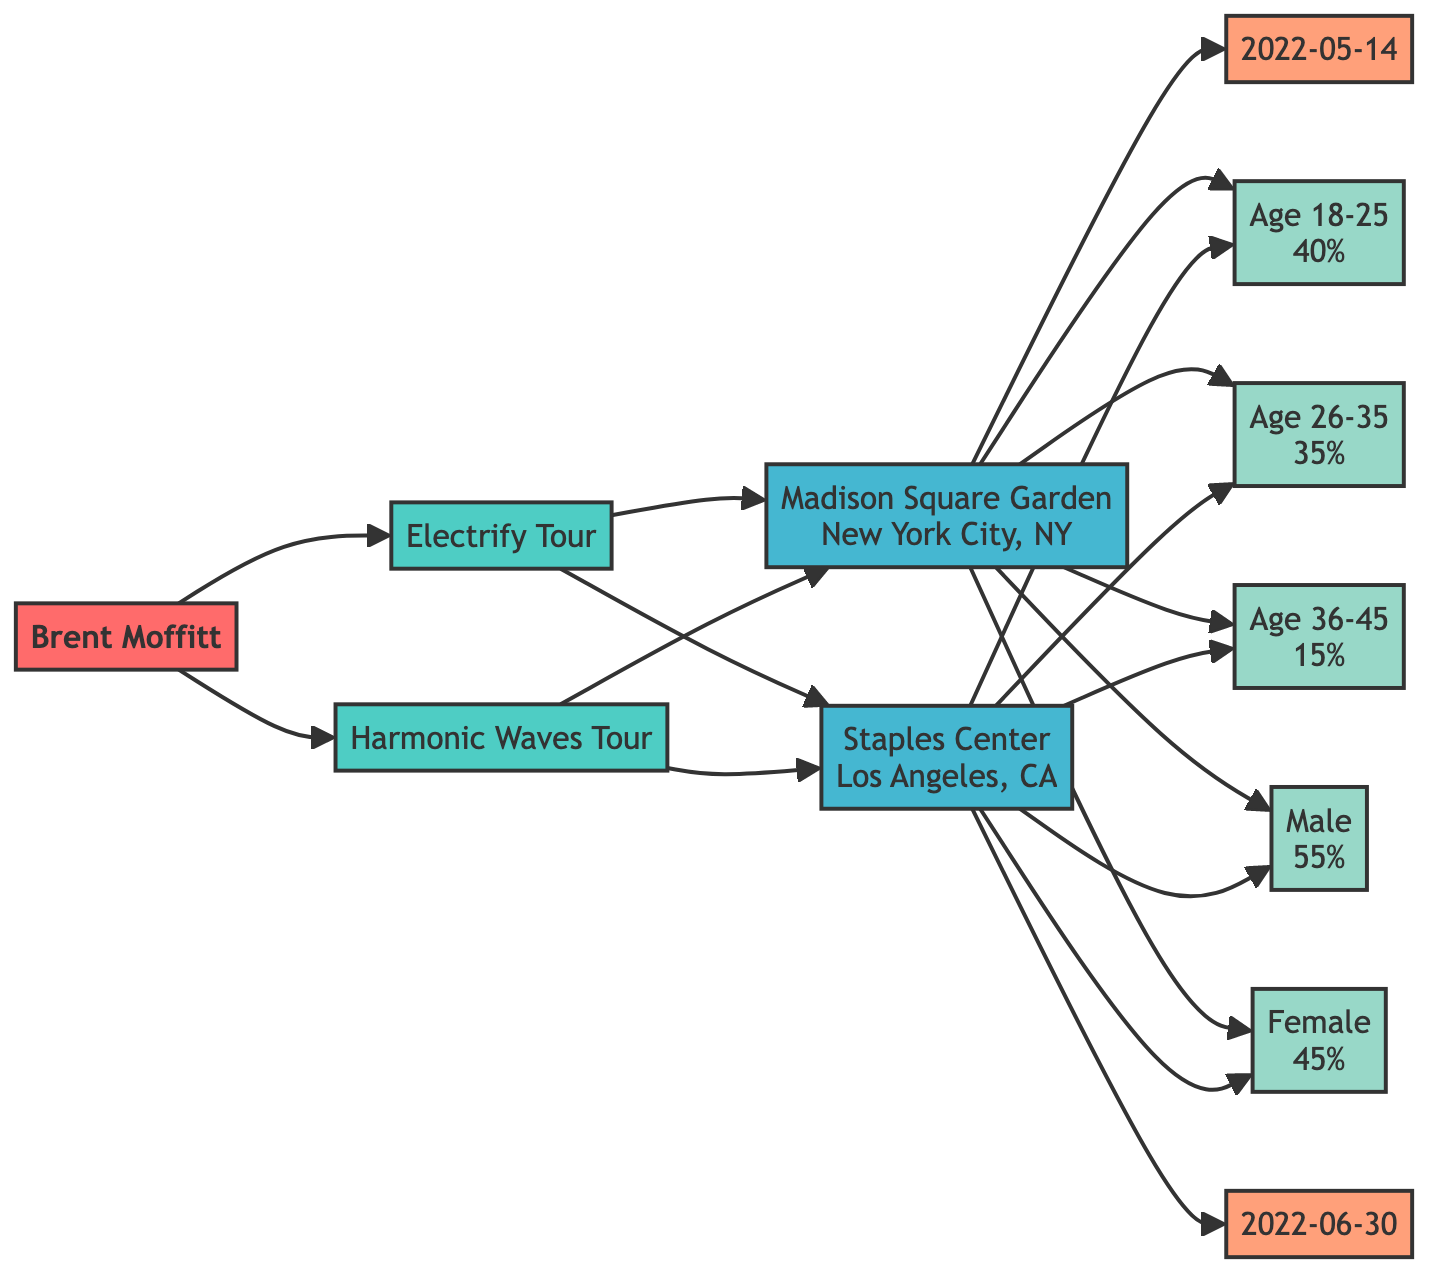What are the two concert tours associated with Brent Moffitt? The diagram shows that Brent Moffitt is associated with two concert tours: "Electrify Tour" and "Harmonic Waves Tour." This information can be directly seen as nodes linked to the artist node.
Answer: Electrify Tour, Harmonic Waves Tour How many venues are associated with each tour? Each tour in the diagram has connections to two venues: "Madison Square Garden" and "Staples Center." This can be verified by counting the edges from the tour nodes to the venue nodes.
Answer: 2 What is the date associated with the Staples Center venue? The diagram links the Staples Center venue to a specific date node, "2022-06-30." Following the edge from the venue node to the date node gives the information.
Answer: 2022-06-30 What percentage of the audience at Madison Square Garden is between the ages of 18-25? The demographic node "Age 18-25" attributes a percentage of "40%" connected directly to the Madison Square Garden venue node. Thus, the percentage is easily extractable from the diagram.
Answer: 40% Which demographic has the highest percentage for the audience at Madison Square Garden? The diagram shows various demographic nodes linked to Madison Square Garden. Scanning through these nodes, "Male" with "55%" is visible, indicating it has the highest percentage.
Answer: Male Which concert tour took place before 2022-06-30? The edges from venues to their corresponding dates help establish that "Electrify Tour" is associated with "2022-05-14," which is before "2022-06-30." The reasoning requires assessing the dates from the venue connections in the tour context.
Answer: Electrify Tour How many demographics are shown for each venue? Each venue node has links to five demographic nodes. By counting the demographic edges connected to each venue, it reveals that both Madison Square Garden and Staples Center have the same number.
Answer: 5 What is the total percentage of the audience demographics aged 26-35 at either venue? The demographic "Age 26-35" has a percentage of "35%" at both venues, but since the question asks only for either venue, it suffices to refer to one venue's demographic data.
Answer: 35% How many edges connect Brent Moffitt to his tours? There are two edges that connect Brent Moffitt to his tours, as indicated by the directed lines from the artist node to the two tour nodes. This relationship can be counted visually from the diagram.
Answer: 2 